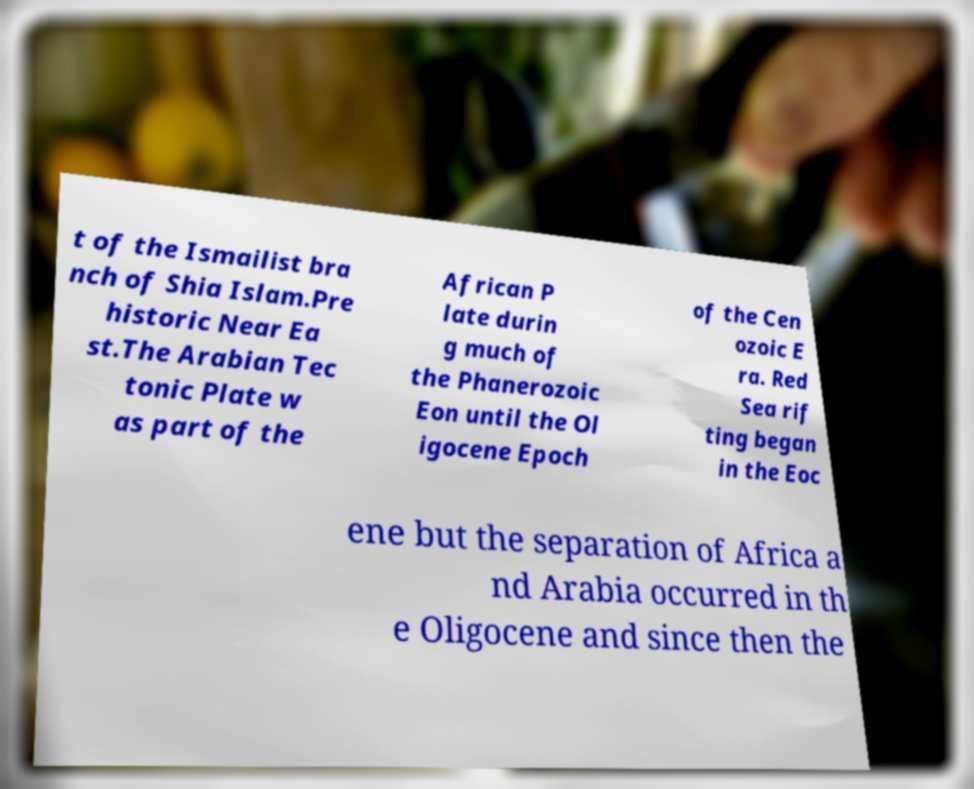Please identify and transcribe the text found in this image. t of the Ismailist bra nch of Shia Islam.Pre historic Near Ea st.The Arabian Tec tonic Plate w as part of the African P late durin g much of the Phanerozoic Eon until the Ol igocene Epoch of the Cen ozoic E ra. Red Sea rif ting began in the Eoc ene but the separation of Africa a nd Arabia occurred in th e Oligocene and since then the 